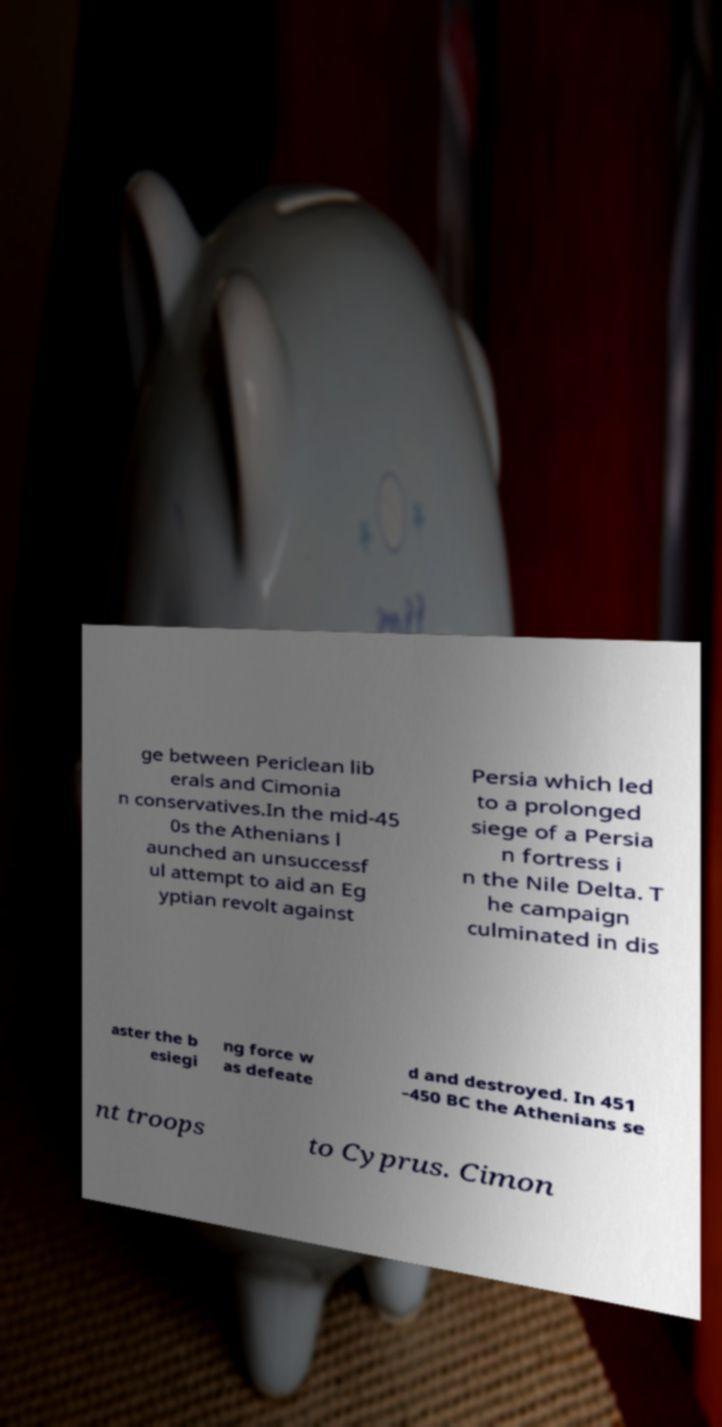There's text embedded in this image that I need extracted. Can you transcribe it verbatim? ge between Periclean lib erals and Cimonia n conservatives.In the mid-45 0s the Athenians l aunched an unsuccessf ul attempt to aid an Eg yptian revolt against Persia which led to a prolonged siege of a Persia n fortress i n the Nile Delta. T he campaign culminated in dis aster the b esiegi ng force w as defeate d and destroyed. In 451 –450 BC the Athenians se nt troops to Cyprus. Cimon 